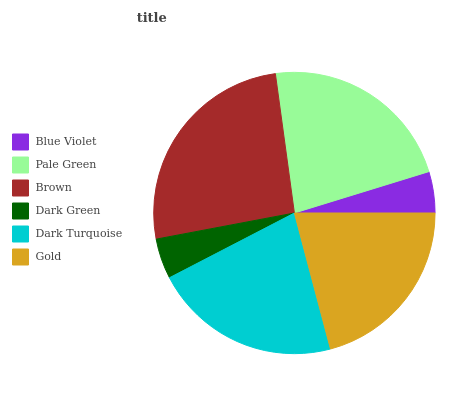Is Dark Green the minimum?
Answer yes or no. Yes. Is Brown the maximum?
Answer yes or no. Yes. Is Pale Green the minimum?
Answer yes or no. No. Is Pale Green the maximum?
Answer yes or no. No. Is Pale Green greater than Blue Violet?
Answer yes or no. Yes. Is Blue Violet less than Pale Green?
Answer yes or no. Yes. Is Blue Violet greater than Pale Green?
Answer yes or no. No. Is Pale Green less than Blue Violet?
Answer yes or no. No. Is Dark Turquoise the high median?
Answer yes or no. Yes. Is Gold the low median?
Answer yes or no. Yes. Is Dark Green the high median?
Answer yes or no. No. Is Blue Violet the low median?
Answer yes or no. No. 